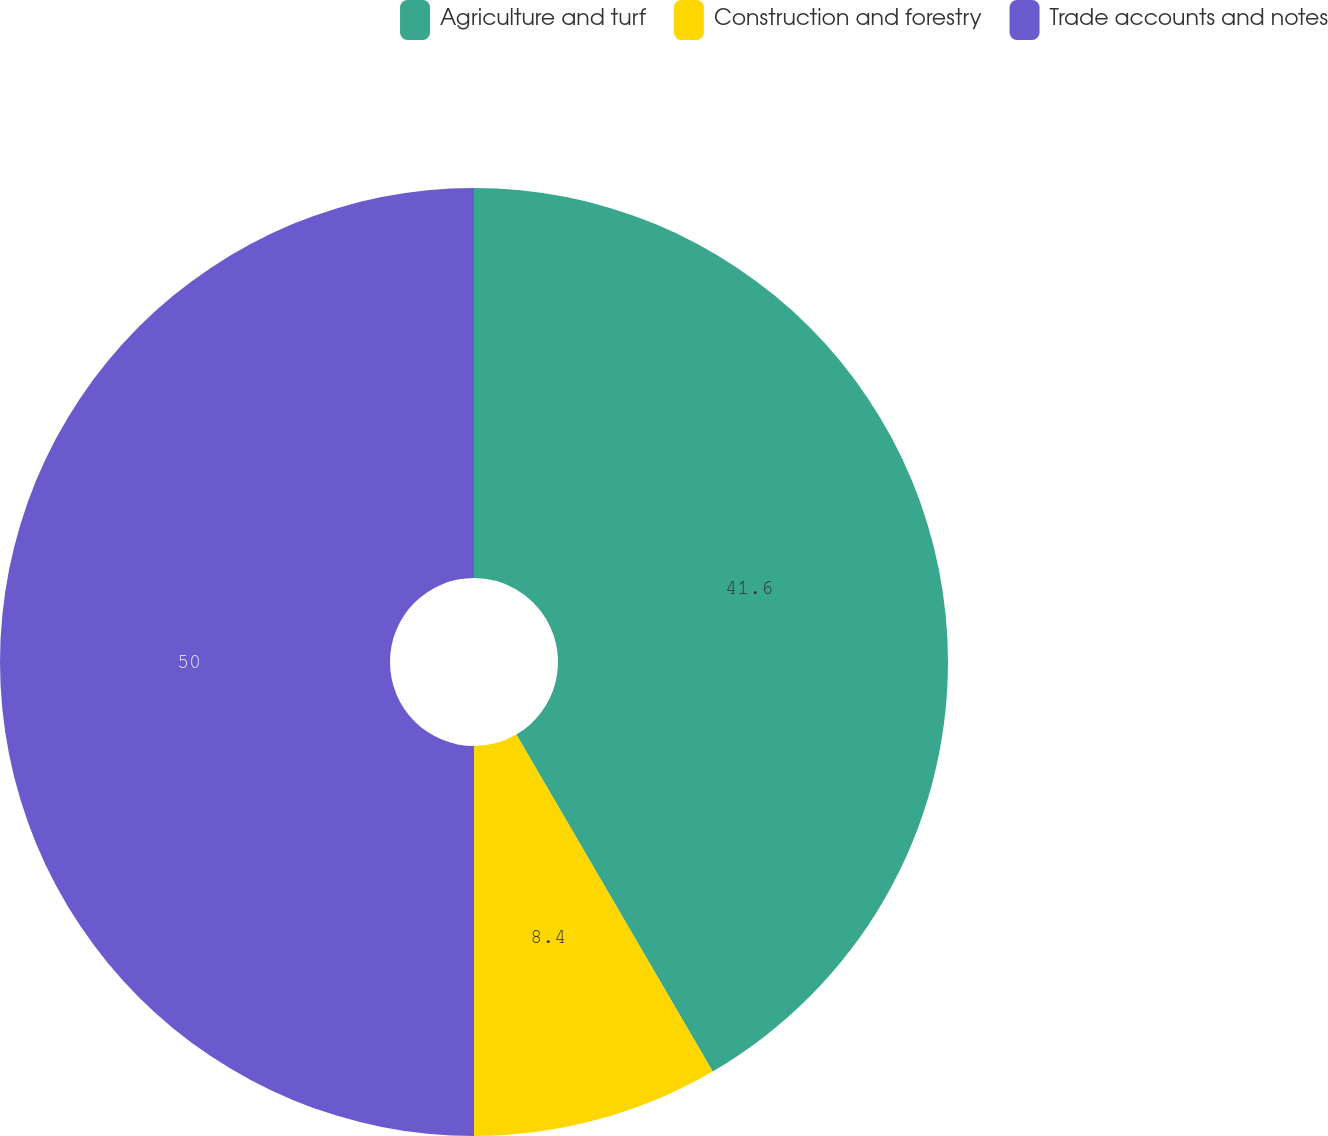Convert chart. <chart><loc_0><loc_0><loc_500><loc_500><pie_chart><fcel>Agriculture and turf<fcel>Construction and forestry<fcel>Trade accounts and notes<nl><fcel>41.6%<fcel>8.4%<fcel>50.0%<nl></chart> 